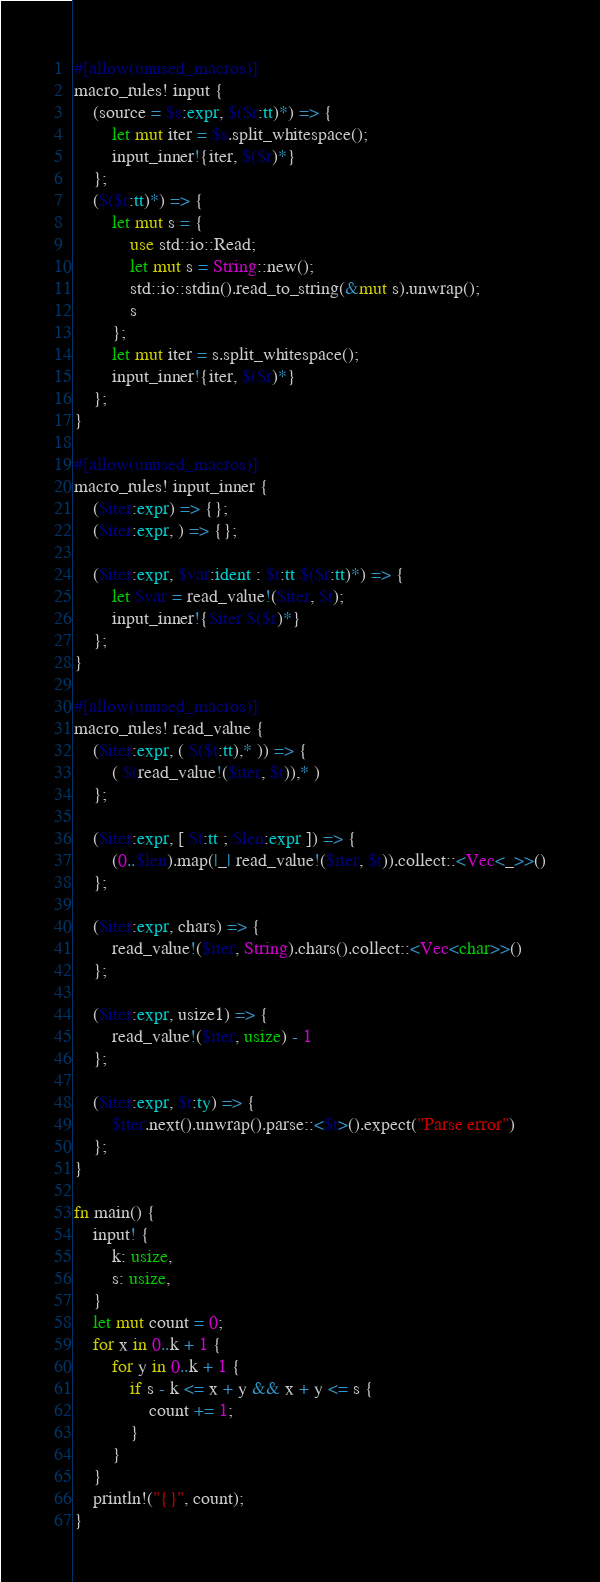<code> <loc_0><loc_0><loc_500><loc_500><_Rust_>#[allow(unused_macros)]
macro_rules! input {
    (source = $s:expr, $($r:tt)*) => {
        let mut iter = $s.split_whitespace();
        input_inner!{iter, $($r)*}
    };
    ($($r:tt)*) => {
        let mut s = {
            use std::io::Read;
            let mut s = String::new();
            std::io::stdin().read_to_string(&mut s).unwrap();
            s
        };
        let mut iter = s.split_whitespace();
        input_inner!{iter, $($r)*}
    };
}

#[allow(unused_macros)]
macro_rules! input_inner {
    ($iter:expr) => {};
    ($iter:expr, ) => {};

    ($iter:expr, $var:ident : $t:tt $($r:tt)*) => {
        let $var = read_value!($iter, $t);
        input_inner!{$iter $($r)*}
    };
}

#[allow(unused_macros)]
macro_rules! read_value {
    ($iter:expr, ( $($t:tt),* )) => {
        ( $(read_value!($iter, $t)),* )
    };

    ($iter:expr, [ $t:tt ; $len:expr ]) => {
        (0..$len).map(|_| read_value!($iter, $t)).collect::<Vec<_>>()
    };

    ($iter:expr, chars) => {
        read_value!($iter, String).chars().collect::<Vec<char>>()
    };

    ($iter:expr, usize1) => {
        read_value!($iter, usize) - 1
    };

    ($iter:expr, $t:ty) => {
        $iter.next().unwrap().parse::<$t>().expect("Parse error")
    };
}

fn main() {
    input! {
        k: usize,
        s: usize,
    }
    let mut count = 0;
    for x in 0..k + 1 {
        for y in 0..k + 1 {
            if s - k <= x + y && x + y <= s {
                count += 1;
            }
        }
    }
    println!("{}", count);
}
</code> 